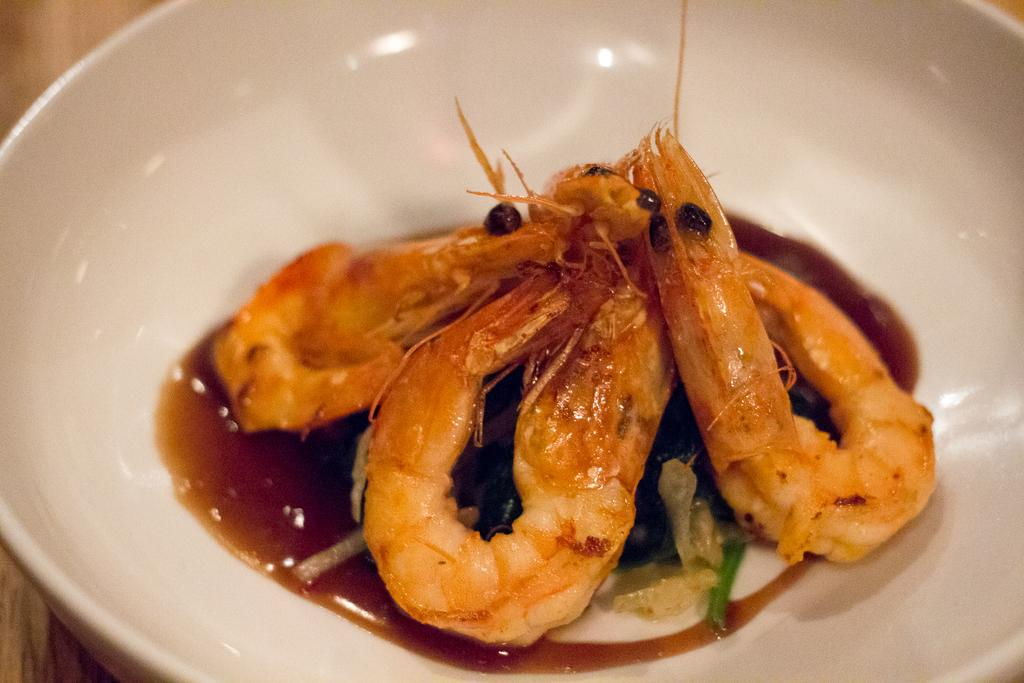What color is the bowl in the image? The bowl in the image is white. What is inside the bowl? The bowl contains food items. On what surface is the bowl placed? The bowl is on a wooden surface. What type of apparatus is being used by the queen in the image? There is no queen or apparatus present in the image. 